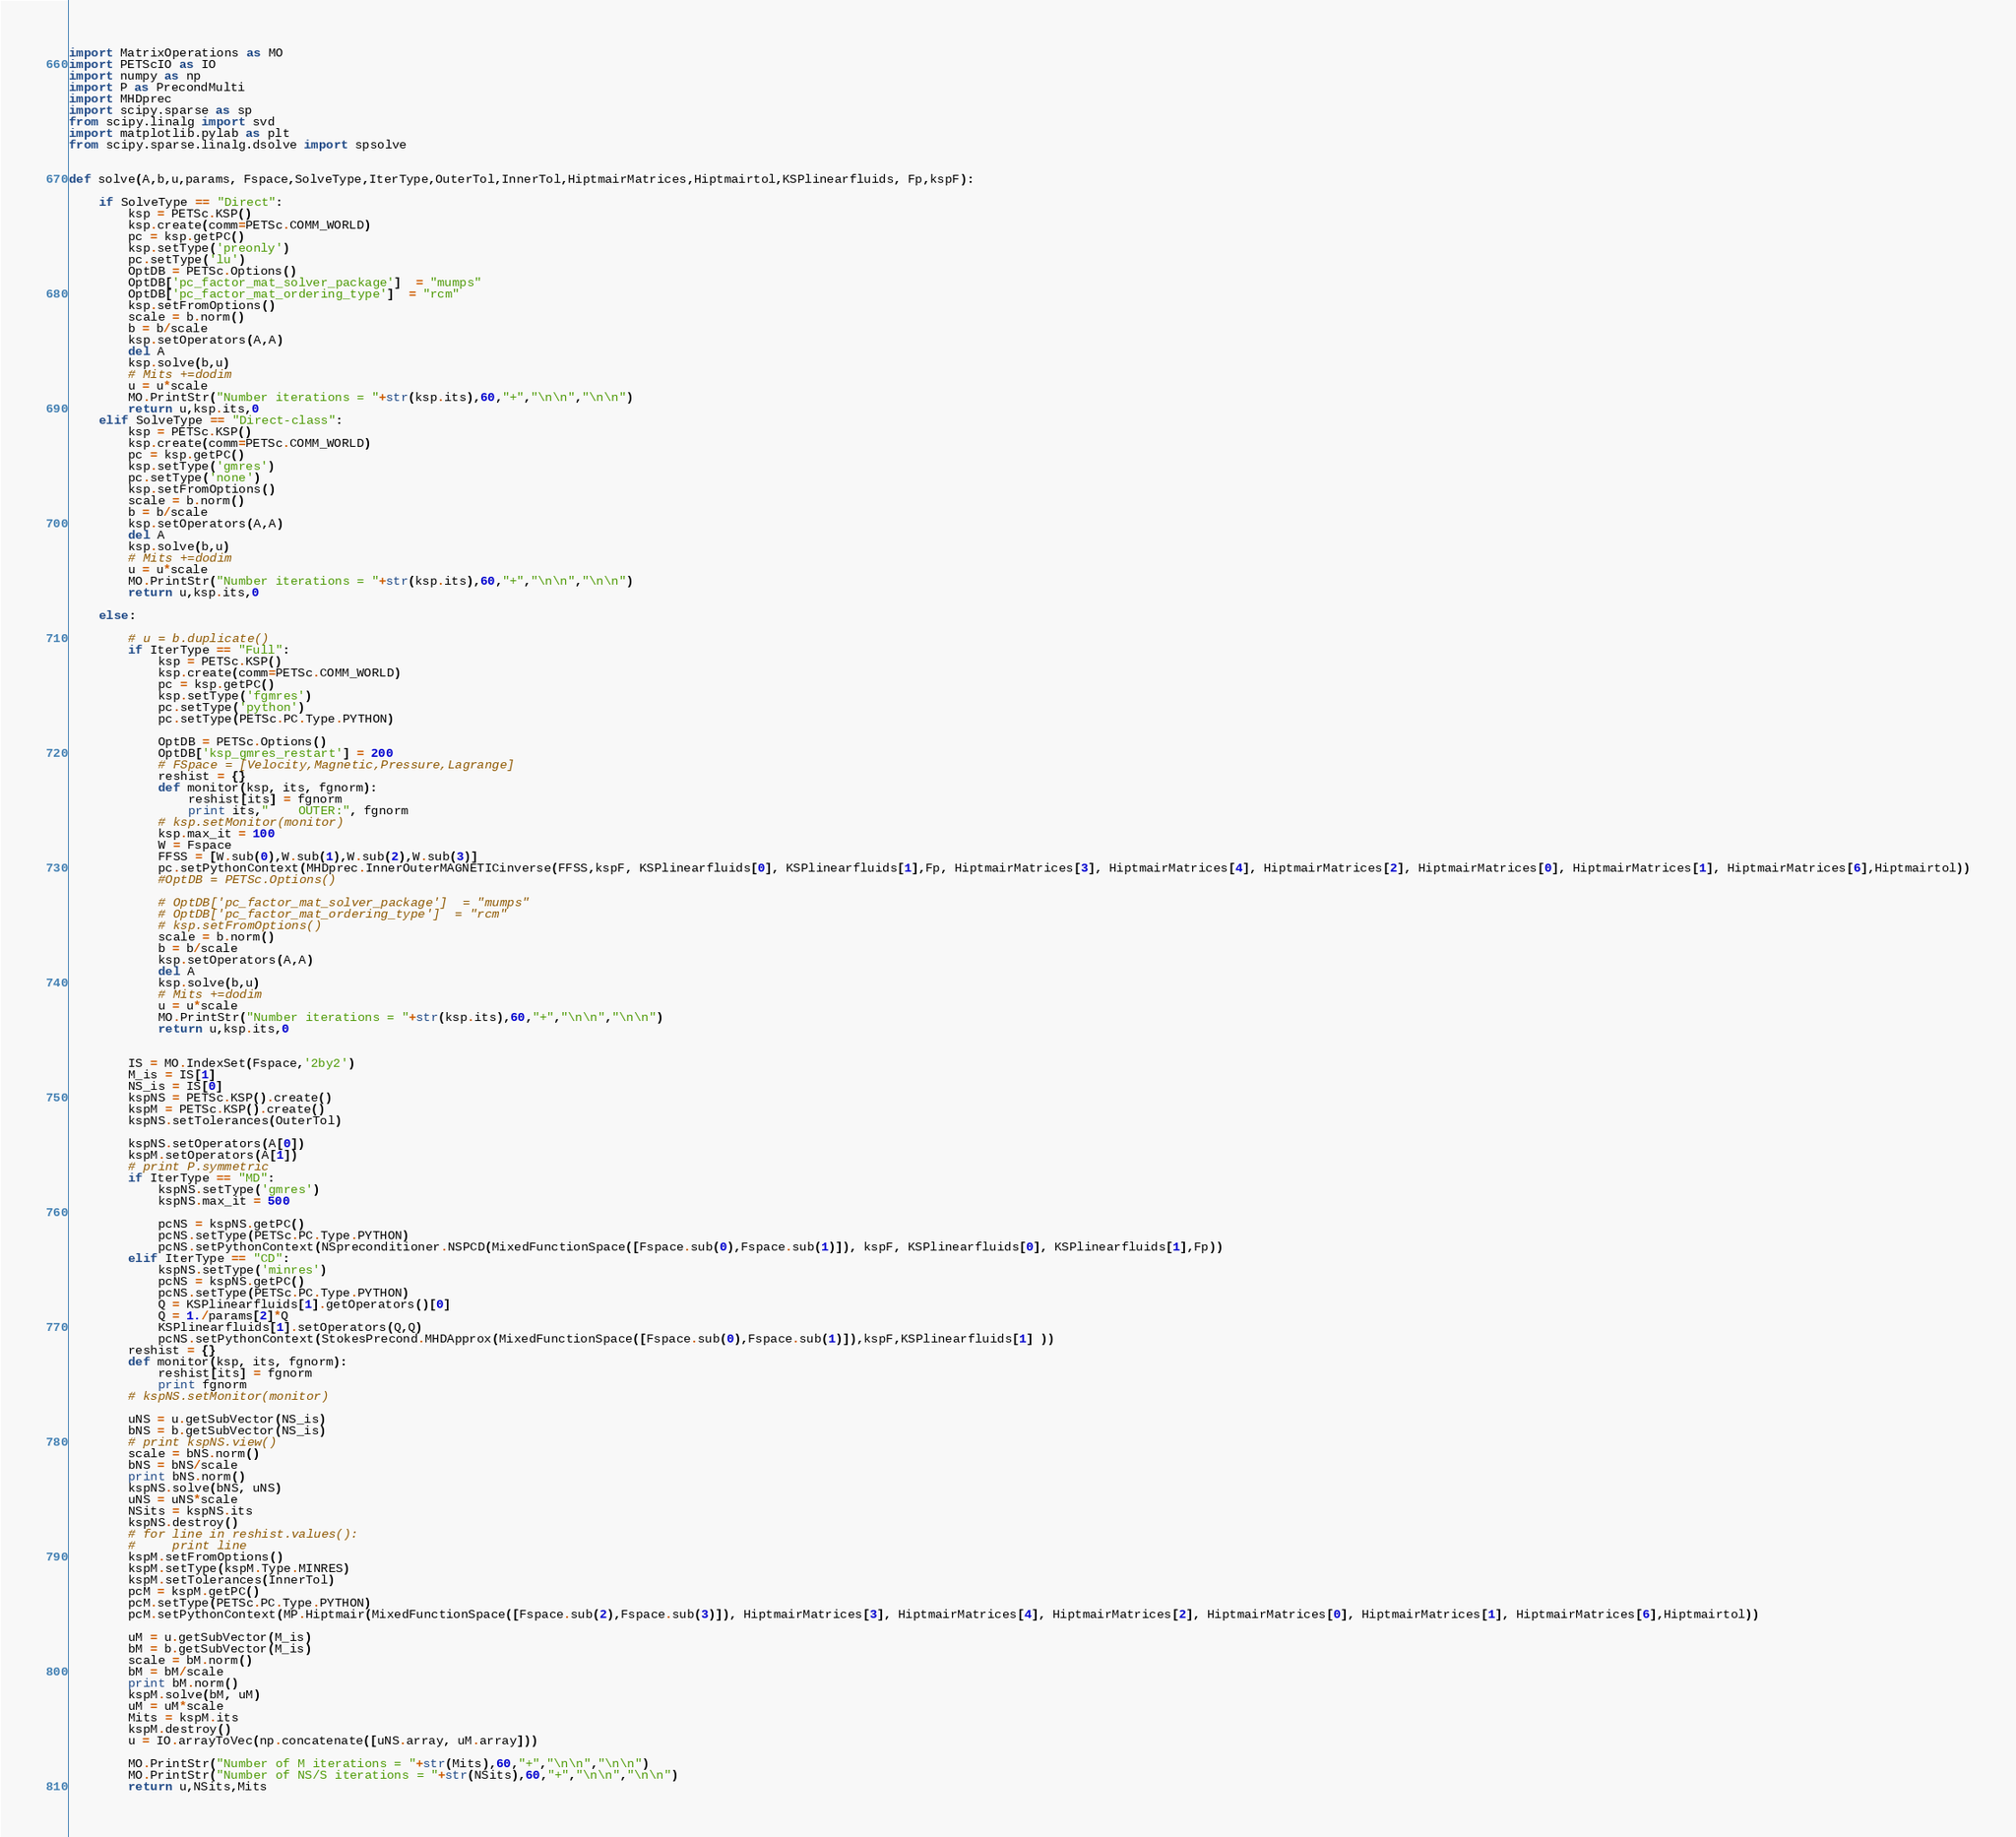Convert code to text. <code><loc_0><loc_0><loc_500><loc_500><_Python_>import MatrixOperations as MO
import PETScIO as IO
import numpy as np
import P as PrecondMulti
import MHDprec
import scipy.sparse as sp
from scipy.linalg import svd
import matplotlib.pylab as plt
from scipy.sparse.linalg.dsolve import spsolve


def solve(A,b,u,params, Fspace,SolveType,IterType,OuterTol,InnerTol,HiptmairMatrices,Hiptmairtol,KSPlinearfluids, Fp,kspF):

    if SolveType == "Direct":
        ksp = PETSc.KSP()
        ksp.create(comm=PETSc.COMM_WORLD)
        pc = ksp.getPC()
        ksp.setType('preonly')
        pc.setType('lu')
        OptDB = PETSc.Options()
        OptDB['pc_factor_mat_solver_package']  = "mumps"
        OptDB['pc_factor_mat_ordering_type']  = "rcm"
        ksp.setFromOptions()
        scale = b.norm()
        b = b/scale
        ksp.setOperators(A,A)
        del A
        ksp.solve(b,u)
        # Mits +=dodim
        u = u*scale
        MO.PrintStr("Number iterations = "+str(ksp.its),60,"+","\n\n","\n\n")
        return u,ksp.its,0
    elif SolveType == "Direct-class":
        ksp = PETSc.KSP()
        ksp.create(comm=PETSc.COMM_WORLD)
        pc = ksp.getPC()
        ksp.setType('gmres')
        pc.setType('none')
        ksp.setFromOptions()
        scale = b.norm()
        b = b/scale
        ksp.setOperators(A,A)
        del A
        ksp.solve(b,u)
        # Mits +=dodim
        u = u*scale
        MO.PrintStr("Number iterations = "+str(ksp.its),60,"+","\n\n","\n\n")
        return u,ksp.its,0

    else:

        # u = b.duplicate()
        if IterType == "Full":
            ksp = PETSc.KSP()
            ksp.create(comm=PETSc.COMM_WORLD)
            pc = ksp.getPC()
            ksp.setType('fgmres')
            pc.setType('python')
            pc.setType(PETSc.PC.Type.PYTHON)

            OptDB = PETSc.Options()
            OptDB['ksp_gmres_restart'] = 200
            # FSpace = [Velocity,Magnetic,Pressure,Lagrange]
            reshist = {}
            def monitor(ksp, its, fgnorm):
                reshist[its] = fgnorm
                print its,"    OUTER:", fgnorm
            # ksp.setMonitor(monitor)
            ksp.max_it = 100
            W = Fspace
            FFSS = [W.sub(0),W.sub(1),W.sub(2),W.sub(3)]
            pc.setPythonContext(MHDprec.InnerOuterMAGNETICinverse(FFSS,kspF, KSPlinearfluids[0], KSPlinearfluids[1],Fp, HiptmairMatrices[3], HiptmairMatrices[4], HiptmairMatrices[2], HiptmairMatrices[0], HiptmairMatrices[1], HiptmairMatrices[6],Hiptmairtol))
            #OptDB = PETSc.Options()

            # OptDB['pc_factor_mat_solver_package']  = "mumps"
            # OptDB['pc_factor_mat_ordering_type']  = "rcm"
            # ksp.setFromOptions()
            scale = b.norm()
            b = b/scale
            ksp.setOperators(A,A)
            del A
            ksp.solve(b,u)
            # Mits +=dodim
            u = u*scale
            MO.PrintStr("Number iterations = "+str(ksp.its),60,"+","\n\n","\n\n")
            return u,ksp.its,0


        IS = MO.IndexSet(Fspace,'2by2')
        M_is = IS[1]
        NS_is = IS[0]
        kspNS = PETSc.KSP().create()
        kspM = PETSc.KSP().create()
        kspNS.setTolerances(OuterTol)

        kspNS.setOperators(A[0])
        kspM.setOperators(A[1])
        # print P.symmetric
        if IterType == "MD":
            kspNS.setType('gmres')
            kspNS.max_it = 500

            pcNS = kspNS.getPC()
            pcNS.setType(PETSc.PC.Type.PYTHON)
            pcNS.setPythonContext(NSpreconditioner.NSPCD(MixedFunctionSpace([Fspace.sub(0),Fspace.sub(1)]), kspF, KSPlinearfluids[0], KSPlinearfluids[1],Fp))
        elif IterType == "CD":
            kspNS.setType('minres')
            pcNS = kspNS.getPC()
            pcNS.setType(PETSc.PC.Type.PYTHON)
            Q = KSPlinearfluids[1].getOperators()[0]
            Q = 1./params[2]*Q
            KSPlinearfluids[1].setOperators(Q,Q)
            pcNS.setPythonContext(StokesPrecond.MHDApprox(MixedFunctionSpace([Fspace.sub(0),Fspace.sub(1)]),kspF,KSPlinearfluids[1] ))
        reshist = {}
        def monitor(ksp, its, fgnorm):
            reshist[its] = fgnorm
            print fgnorm
        # kspNS.setMonitor(monitor)

        uNS = u.getSubVector(NS_is)
        bNS = b.getSubVector(NS_is)
        # print kspNS.view()
        scale = bNS.norm()
        bNS = bNS/scale
        print bNS.norm()
        kspNS.solve(bNS, uNS)
        uNS = uNS*scale
        NSits = kspNS.its
        kspNS.destroy()
        # for line in reshist.values():
        #     print line
        kspM.setFromOptions()
        kspM.setType(kspM.Type.MINRES)
        kspM.setTolerances(InnerTol)
        pcM = kspM.getPC()
        pcM.setType(PETSc.PC.Type.PYTHON)
        pcM.setPythonContext(MP.Hiptmair(MixedFunctionSpace([Fspace.sub(2),Fspace.sub(3)]), HiptmairMatrices[3], HiptmairMatrices[4], HiptmairMatrices[2], HiptmairMatrices[0], HiptmairMatrices[1], HiptmairMatrices[6],Hiptmairtol))

        uM = u.getSubVector(M_is)
        bM = b.getSubVector(M_is)
        scale = bM.norm()
        bM = bM/scale
        print bM.norm()
        kspM.solve(bM, uM)
        uM = uM*scale
        Mits = kspM.its
        kspM.destroy()
        u = IO.arrayToVec(np.concatenate([uNS.array, uM.array]))

        MO.PrintStr("Number of M iterations = "+str(Mits),60,"+","\n\n","\n\n")
        MO.PrintStr("Number of NS/S iterations = "+str(NSits),60,"+","\n\n","\n\n")
        return u,NSits,Mits





</code> 